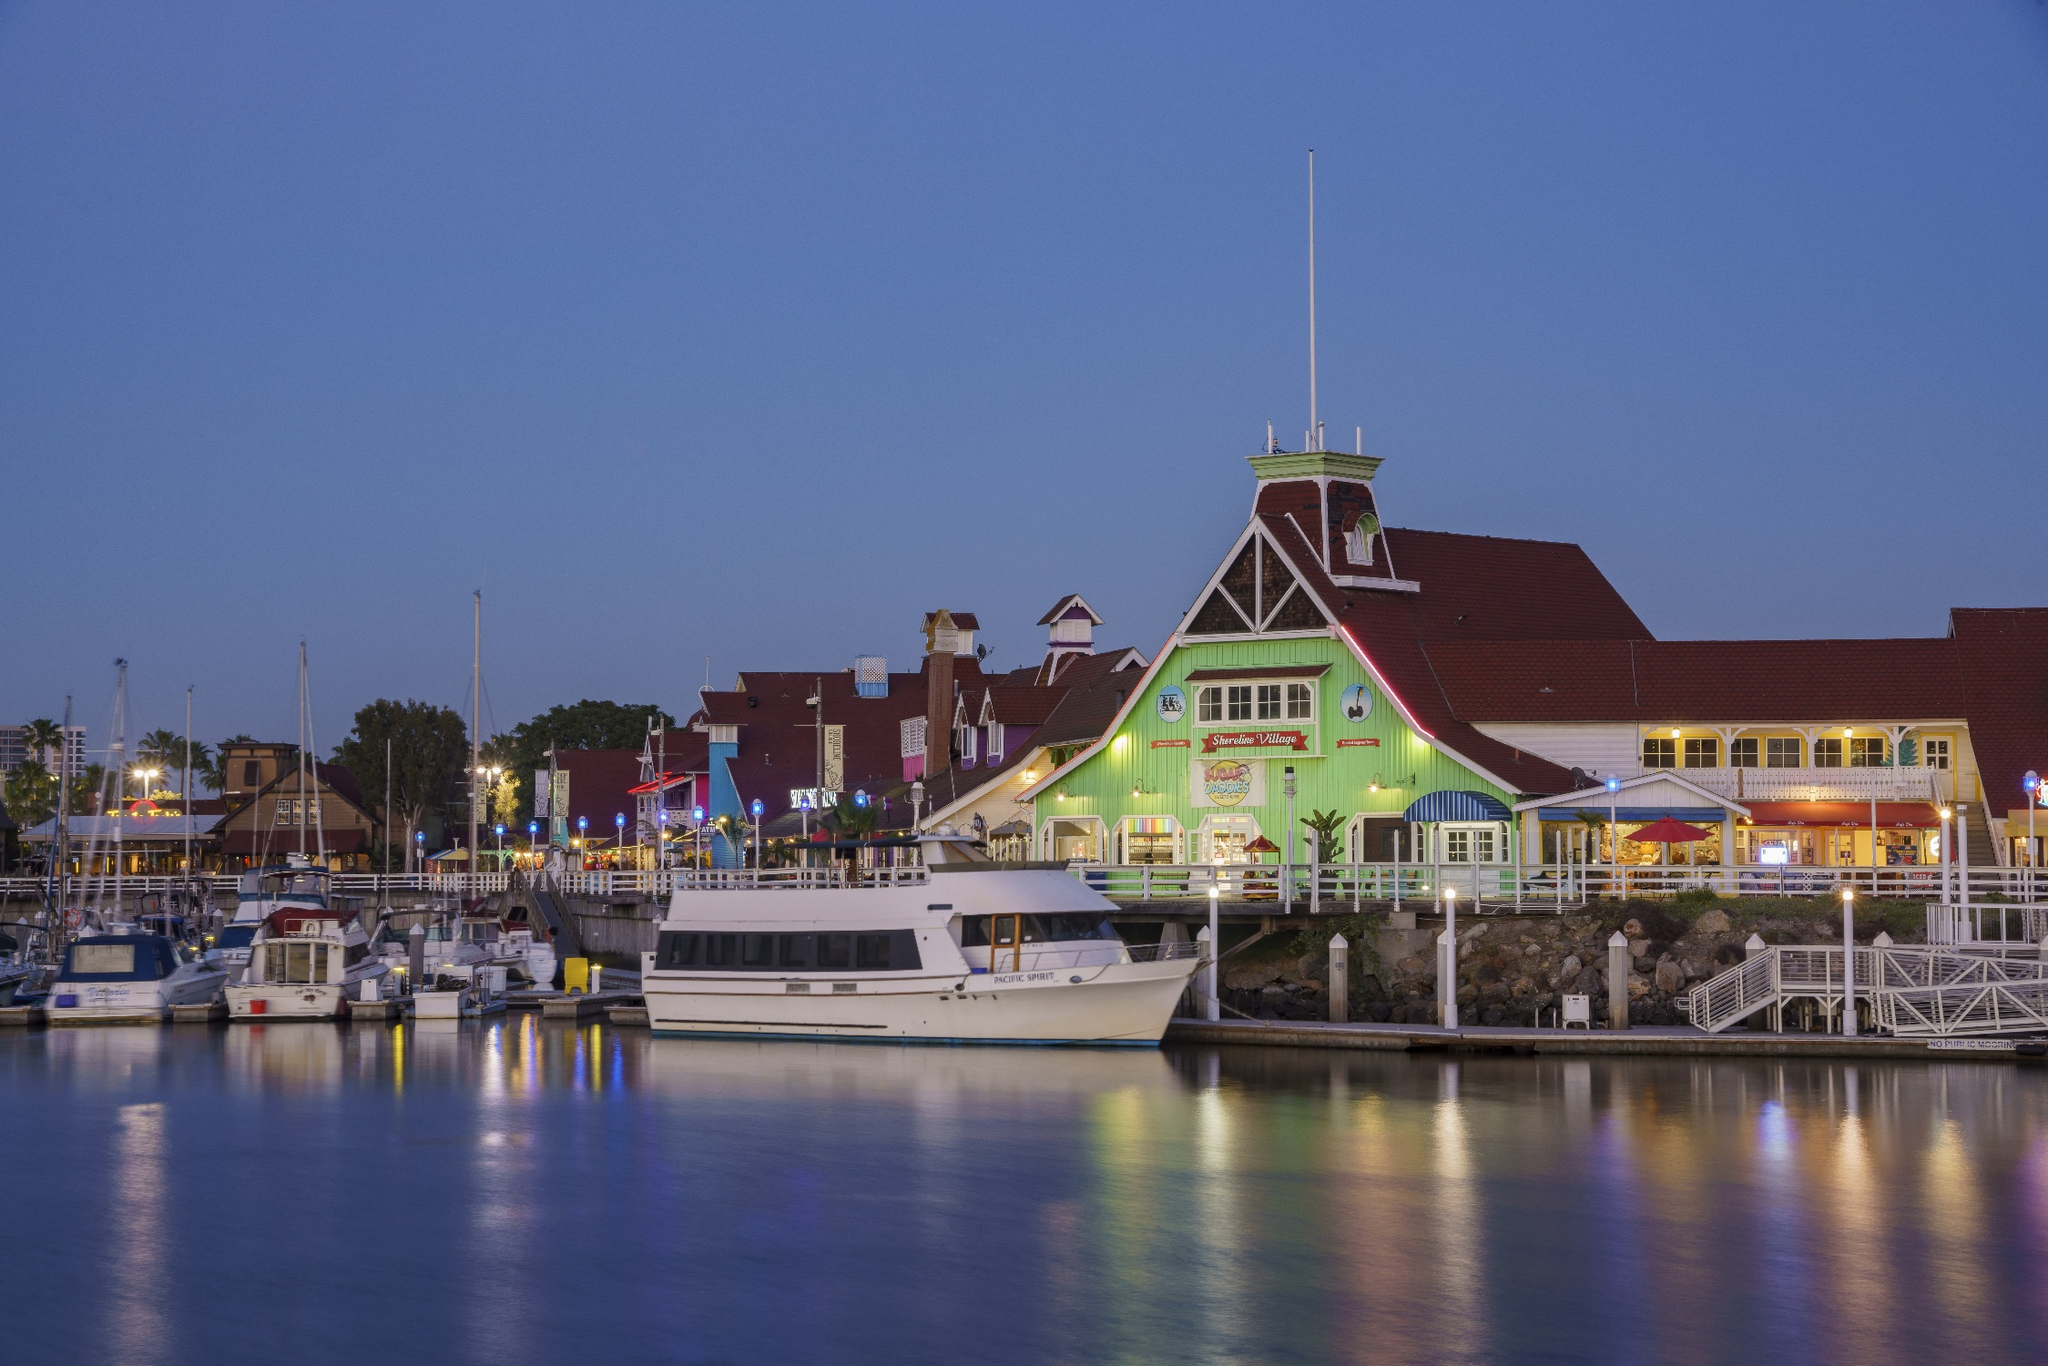Describe the following image. The image beautifully captures the Long Beach Shoreline Marina in California from the water's perspective, showcasing a serene and tranquil evening. The marina is dotted with various boats, reflecting gently in the calm, still water. On the shore, buildings are adorned with a spectrum of colorful lights, creating a vibrant atmosphere. The sky is a deep, rich blue, enhancing the overall tranquility of the scene. Prominently featured is Parkers' Lighthouse, a renowned restaurant marked by its distinctive green exterior, which stands charmingly against the backdrop of the dusk-filled sky. The entire scene exudes a picturesque and peaceful charm, emphasizing the scenic beauty of this iconic landmark. 